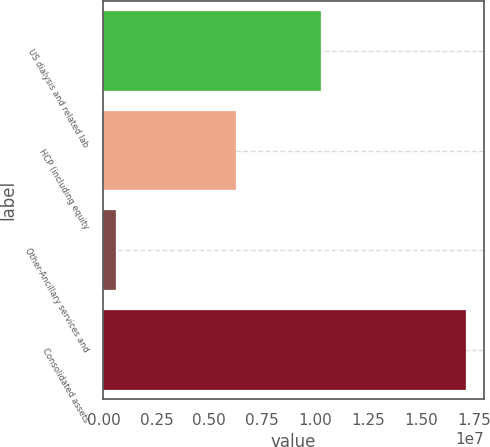<chart> <loc_0><loc_0><loc_500><loc_500><bar_chart><fcel>US dialysis and related lab<fcel>HCP (including equity<fcel>Other-Ancillary services and<fcel>Consolidated assets<nl><fcel>1.0249e+07<fcel>6.26577e+06<fcel>584117<fcel>1.70989e+07<nl></chart> 